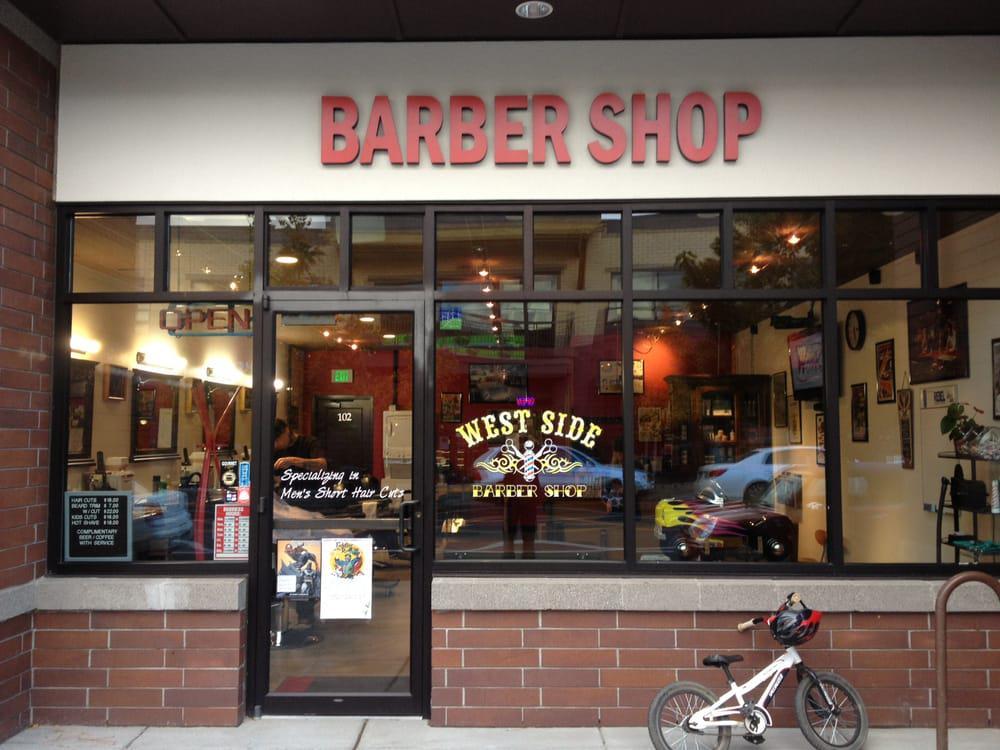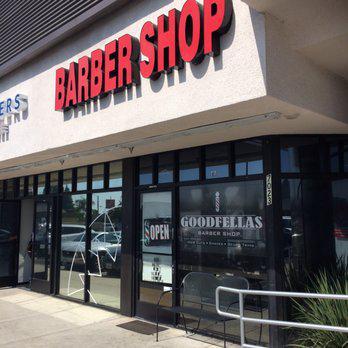The first image is the image on the left, the second image is the image on the right. Considering the images on both sides, is "A barber shop has a red brick exterior with a row of black-rimmed windows parallel to the sidewalk." valid? Answer yes or no. Yes. 